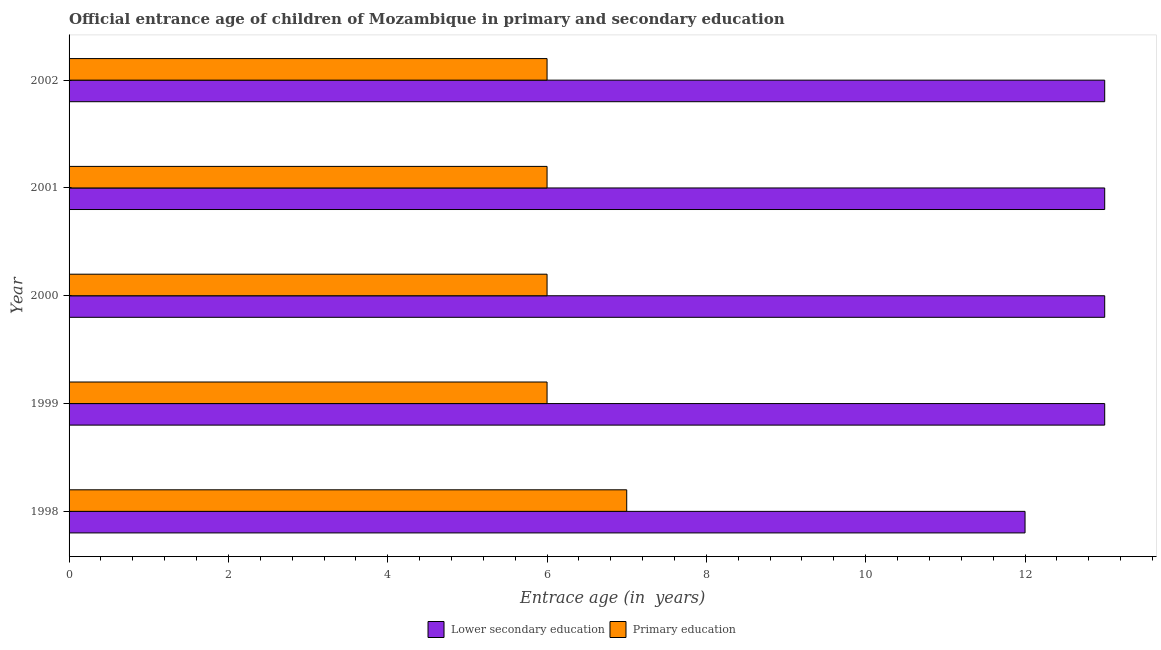How many different coloured bars are there?
Provide a short and direct response. 2. Are the number of bars on each tick of the Y-axis equal?
Provide a succinct answer. Yes. How many bars are there on the 5th tick from the top?
Offer a terse response. 2. How many bars are there on the 4th tick from the bottom?
Make the answer very short. 2. In how many cases, is the number of bars for a given year not equal to the number of legend labels?
Ensure brevity in your answer.  0. What is the entrance age of children in lower secondary education in 1998?
Make the answer very short. 12. Across all years, what is the maximum entrance age of chiildren in primary education?
Keep it short and to the point. 7. Across all years, what is the minimum entrance age of chiildren in primary education?
Provide a short and direct response. 6. What is the total entrance age of chiildren in primary education in the graph?
Offer a very short reply. 31. What is the difference between the entrance age of chiildren in primary education in 2000 and the entrance age of children in lower secondary education in 2001?
Your answer should be compact. -7. What is the average entrance age of chiildren in primary education per year?
Provide a succinct answer. 6.2. In the year 1998, what is the difference between the entrance age of chiildren in primary education and entrance age of children in lower secondary education?
Offer a very short reply. -5. In how many years, is the entrance age of children in lower secondary education greater than 13.2 years?
Ensure brevity in your answer.  0. Is the entrance age of children in lower secondary education in 1999 less than that in 2001?
Provide a succinct answer. No. What is the difference between the highest and the second highest entrance age of children in lower secondary education?
Provide a short and direct response. 0. What is the difference between the highest and the lowest entrance age of children in lower secondary education?
Your answer should be compact. 1. Is the sum of the entrance age of children in lower secondary education in 1999 and 2000 greater than the maximum entrance age of chiildren in primary education across all years?
Your answer should be very brief. Yes. What does the 1st bar from the top in 1999 represents?
Offer a very short reply. Primary education. Does the graph contain any zero values?
Your response must be concise. No. Where does the legend appear in the graph?
Your answer should be compact. Bottom center. How many legend labels are there?
Give a very brief answer. 2. What is the title of the graph?
Ensure brevity in your answer.  Official entrance age of children of Mozambique in primary and secondary education. What is the label or title of the X-axis?
Give a very brief answer. Entrace age (in  years). What is the label or title of the Y-axis?
Offer a very short reply. Year. What is the Entrace age (in  years) of Lower secondary education in 1998?
Offer a very short reply. 12. What is the Entrace age (in  years) of Lower secondary education in 2000?
Offer a terse response. 13. What is the Entrace age (in  years) of Primary education in 2000?
Give a very brief answer. 6. What is the Entrace age (in  years) of Lower secondary education in 2001?
Provide a succinct answer. 13. What is the Entrace age (in  years) of Lower secondary education in 2002?
Keep it short and to the point. 13. What is the Entrace age (in  years) in Primary education in 2002?
Ensure brevity in your answer.  6. Across all years, what is the minimum Entrace age (in  years) in Lower secondary education?
Offer a terse response. 12. What is the total Entrace age (in  years) in Lower secondary education in the graph?
Offer a very short reply. 64. What is the difference between the Entrace age (in  years) of Primary education in 1998 and that in 2000?
Provide a short and direct response. 1. What is the difference between the Entrace age (in  years) of Lower secondary education in 1998 and that in 2002?
Your answer should be compact. -1. What is the difference between the Entrace age (in  years) in Primary education in 1998 and that in 2002?
Offer a very short reply. 1. What is the difference between the Entrace age (in  years) of Lower secondary education in 1999 and that in 2000?
Offer a terse response. 0. What is the difference between the Entrace age (in  years) of Primary education in 1999 and that in 2000?
Offer a very short reply. 0. What is the difference between the Entrace age (in  years) of Primary education in 1999 and that in 2001?
Your answer should be compact. 0. What is the difference between the Entrace age (in  years) in Primary education in 1999 and that in 2002?
Make the answer very short. 0. What is the difference between the Entrace age (in  years) of Lower secondary education in 2000 and that in 2001?
Your response must be concise. 0. What is the difference between the Entrace age (in  years) in Lower secondary education in 2001 and that in 2002?
Provide a succinct answer. 0. What is the difference between the Entrace age (in  years) in Lower secondary education in 1999 and the Entrace age (in  years) in Primary education in 2001?
Provide a short and direct response. 7. What is the difference between the Entrace age (in  years) in Lower secondary education in 2000 and the Entrace age (in  years) in Primary education in 2002?
Keep it short and to the point. 7. What is the difference between the Entrace age (in  years) in Lower secondary education in 2001 and the Entrace age (in  years) in Primary education in 2002?
Give a very brief answer. 7. In the year 1998, what is the difference between the Entrace age (in  years) of Lower secondary education and Entrace age (in  years) of Primary education?
Give a very brief answer. 5. In the year 1999, what is the difference between the Entrace age (in  years) in Lower secondary education and Entrace age (in  years) in Primary education?
Ensure brevity in your answer.  7. In the year 2000, what is the difference between the Entrace age (in  years) in Lower secondary education and Entrace age (in  years) in Primary education?
Provide a short and direct response. 7. What is the ratio of the Entrace age (in  years) in Lower secondary education in 1998 to that in 1999?
Offer a very short reply. 0.92. What is the ratio of the Entrace age (in  years) in Primary education in 1998 to that in 2001?
Your response must be concise. 1.17. What is the ratio of the Entrace age (in  years) in Primary education in 1998 to that in 2002?
Your answer should be compact. 1.17. What is the ratio of the Entrace age (in  years) of Lower secondary education in 1999 to that in 2000?
Your answer should be very brief. 1. What is the ratio of the Entrace age (in  years) in Primary education in 1999 to that in 2000?
Provide a succinct answer. 1. What is the ratio of the Entrace age (in  years) in Primary education in 1999 to that in 2001?
Keep it short and to the point. 1. What is the ratio of the Entrace age (in  years) of Primary education in 2000 to that in 2001?
Your response must be concise. 1. What is the ratio of the Entrace age (in  years) of Lower secondary education in 2001 to that in 2002?
Your answer should be very brief. 1. What is the ratio of the Entrace age (in  years) of Primary education in 2001 to that in 2002?
Provide a succinct answer. 1. What is the difference between the highest and the second highest Entrace age (in  years) in Lower secondary education?
Offer a very short reply. 0. What is the difference between the highest and the lowest Entrace age (in  years) in Lower secondary education?
Offer a very short reply. 1. 